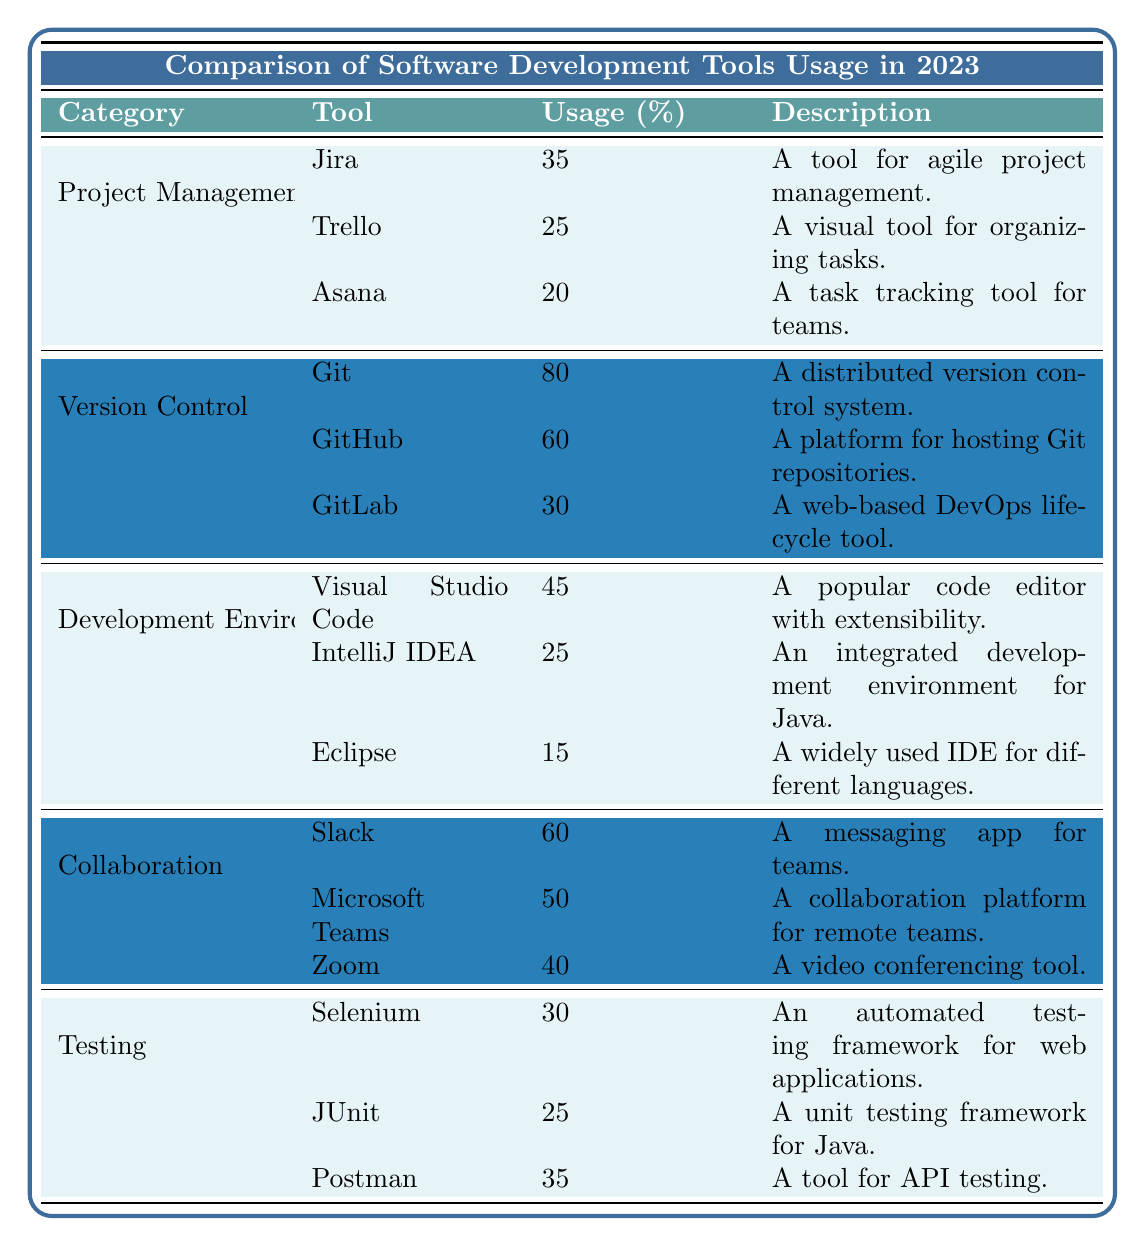What is the usage percentage of Git in Version Control? The table lists Git under the Version Control category and indicates its Usage Percentage as 80%.
Answer: 80% Which tool has the highest usage in Project Management? In the Project Management category, Jira has the highest Usage Percentage at 35%.
Answer: Jira What is the total usage percentage for all tools in the Collaboration category? Adding the usage percentages: Slack (60) + Microsoft Teams (50) + Zoom (40) gives a sum of 150%.
Answer: 150% Is Visual Studio Code used more than IntelliJ IDEA? Visual Studio Code has a Usage Percentage of 45%, while IntelliJ IDEA has 25%. Therefore, it is true that Visual Studio Code is used more.
Answer: Yes Which category has the lowest overall usage? Upon reviewing all categories, Development Environments has the lowest percentage: 15% for Eclipse is lower than all other categories' lowest values.
Answer: Development Environments What percentage of Project Management tools have a usage over 30%? Out of the three tools in Project Management, only Jira (35%) qualifies. Therefore, only 1 out of 3 tools meets this criterion, giving a percentage of (1/3)*100 = 33.33%.
Answer: 33.33% How does the usage of Git compare with the average usage of tools in Development Environments? The tools in Development Environments have usages of 45%, 25%, and 15%. The average is (45 + 25 + 15) / 3 = 28.33%. Git at 80% is significantly higher than the average.
Answer: Git is higher What is the difference in usage percentage between Slack and Zoom? Slack has a usage percentage of 60%, and Zoom has 40%. The difference is 60 - 40 = 20%.
Answer: 20% Is it true that Postman has a higher usage than JUnit? Postman has a usage percentage of 35%, while JUnit has 25%. Since 35% is greater than 25%, it is true.
Answer: Yes Which tool from the Testing category has the lowest usage? In the Testing category, JUnit has the lowest usage at 25%.
Answer: JUnit 